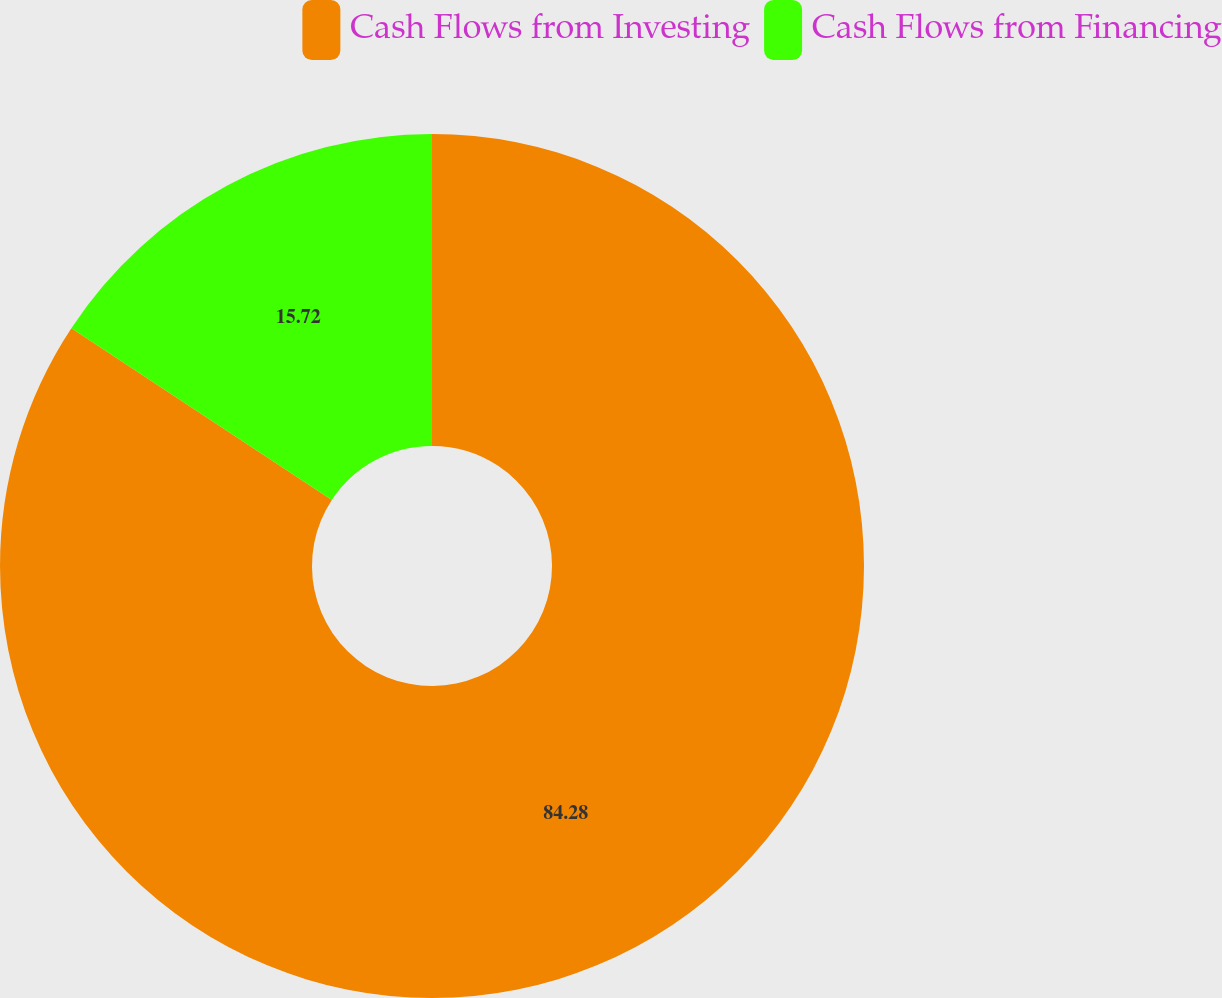Convert chart to OTSL. <chart><loc_0><loc_0><loc_500><loc_500><pie_chart><fcel>Cash Flows from Investing<fcel>Cash Flows from Financing<nl><fcel>84.28%<fcel>15.72%<nl></chart> 